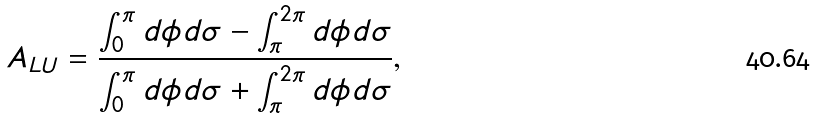<formula> <loc_0><loc_0><loc_500><loc_500>A _ { L U } = \frac { \int _ { 0 } ^ { \pi } d \phi d \sigma - \int _ { \pi } ^ { 2 \pi } d \phi d \sigma } { \int _ { 0 } ^ { \pi } d \phi d \sigma + \int _ { \pi } ^ { 2 \pi } d \phi d \sigma } ,</formula> 